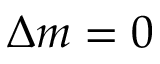Convert formula to latex. <formula><loc_0><loc_0><loc_500><loc_500>\Delta m = 0</formula> 